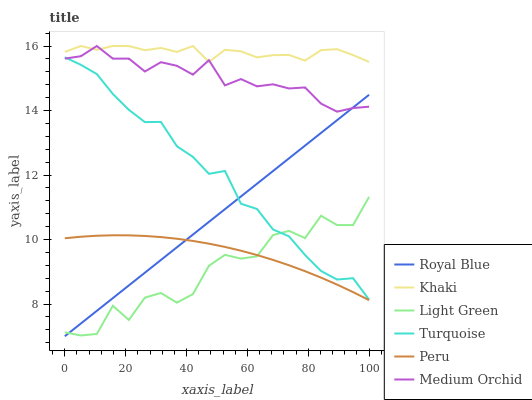Does Light Green have the minimum area under the curve?
Answer yes or no. Yes. Does Khaki have the maximum area under the curve?
Answer yes or no. Yes. Does Khaki have the minimum area under the curve?
Answer yes or no. No. Does Light Green have the maximum area under the curve?
Answer yes or no. No. Is Royal Blue the smoothest?
Answer yes or no. Yes. Is Light Green the roughest?
Answer yes or no. Yes. Is Khaki the smoothest?
Answer yes or no. No. Is Khaki the roughest?
Answer yes or no. No. Does Royal Blue have the lowest value?
Answer yes or no. Yes. Does Light Green have the lowest value?
Answer yes or no. No. Does Medium Orchid have the highest value?
Answer yes or no. Yes. Does Light Green have the highest value?
Answer yes or no. No. Is Light Green less than Medium Orchid?
Answer yes or no. Yes. Is Medium Orchid greater than Light Green?
Answer yes or no. Yes. Does Khaki intersect Medium Orchid?
Answer yes or no. Yes. Is Khaki less than Medium Orchid?
Answer yes or no. No. Is Khaki greater than Medium Orchid?
Answer yes or no. No. Does Light Green intersect Medium Orchid?
Answer yes or no. No. 